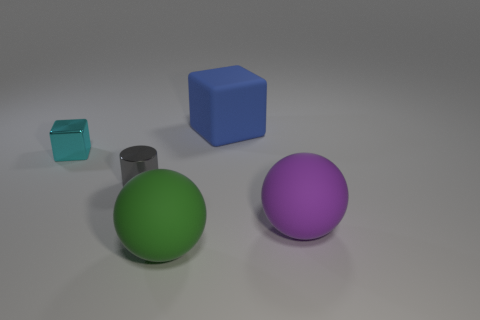Add 1 yellow shiny cubes. How many objects exist? 6 Subtract all cubes. How many objects are left? 3 Add 1 tiny cyan shiny things. How many tiny cyan shiny things exist? 2 Subtract 0 cyan cylinders. How many objects are left? 5 Subtract all brown metal blocks. Subtract all green rubber things. How many objects are left? 4 Add 2 green spheres. How many green spheres are left? 3 